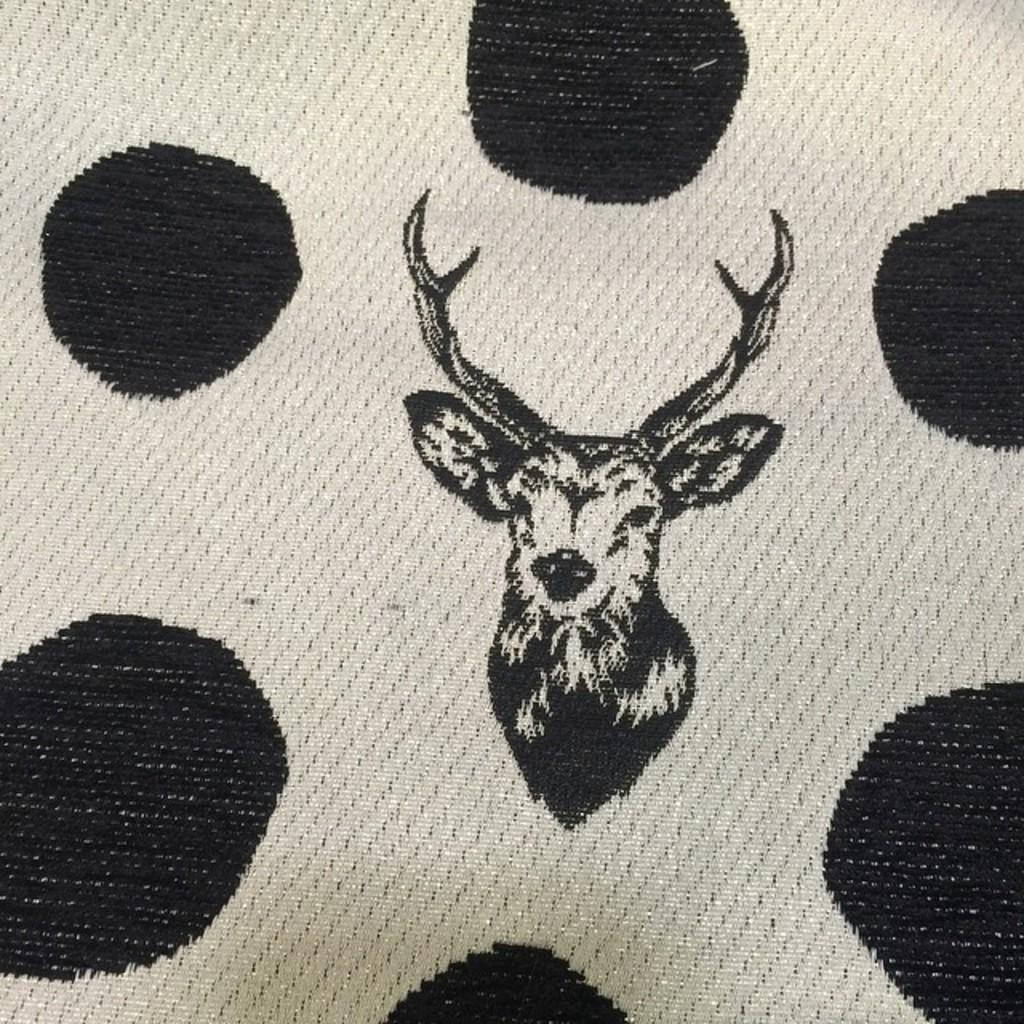What is the main object in the image? There is a cloth in the image. What is depicted on the cloth? The cloth has an image of a deer. Who is the owner of the chin depicted on the cloth? There is no chin depicted on the cloth; it features an image of a deer. 